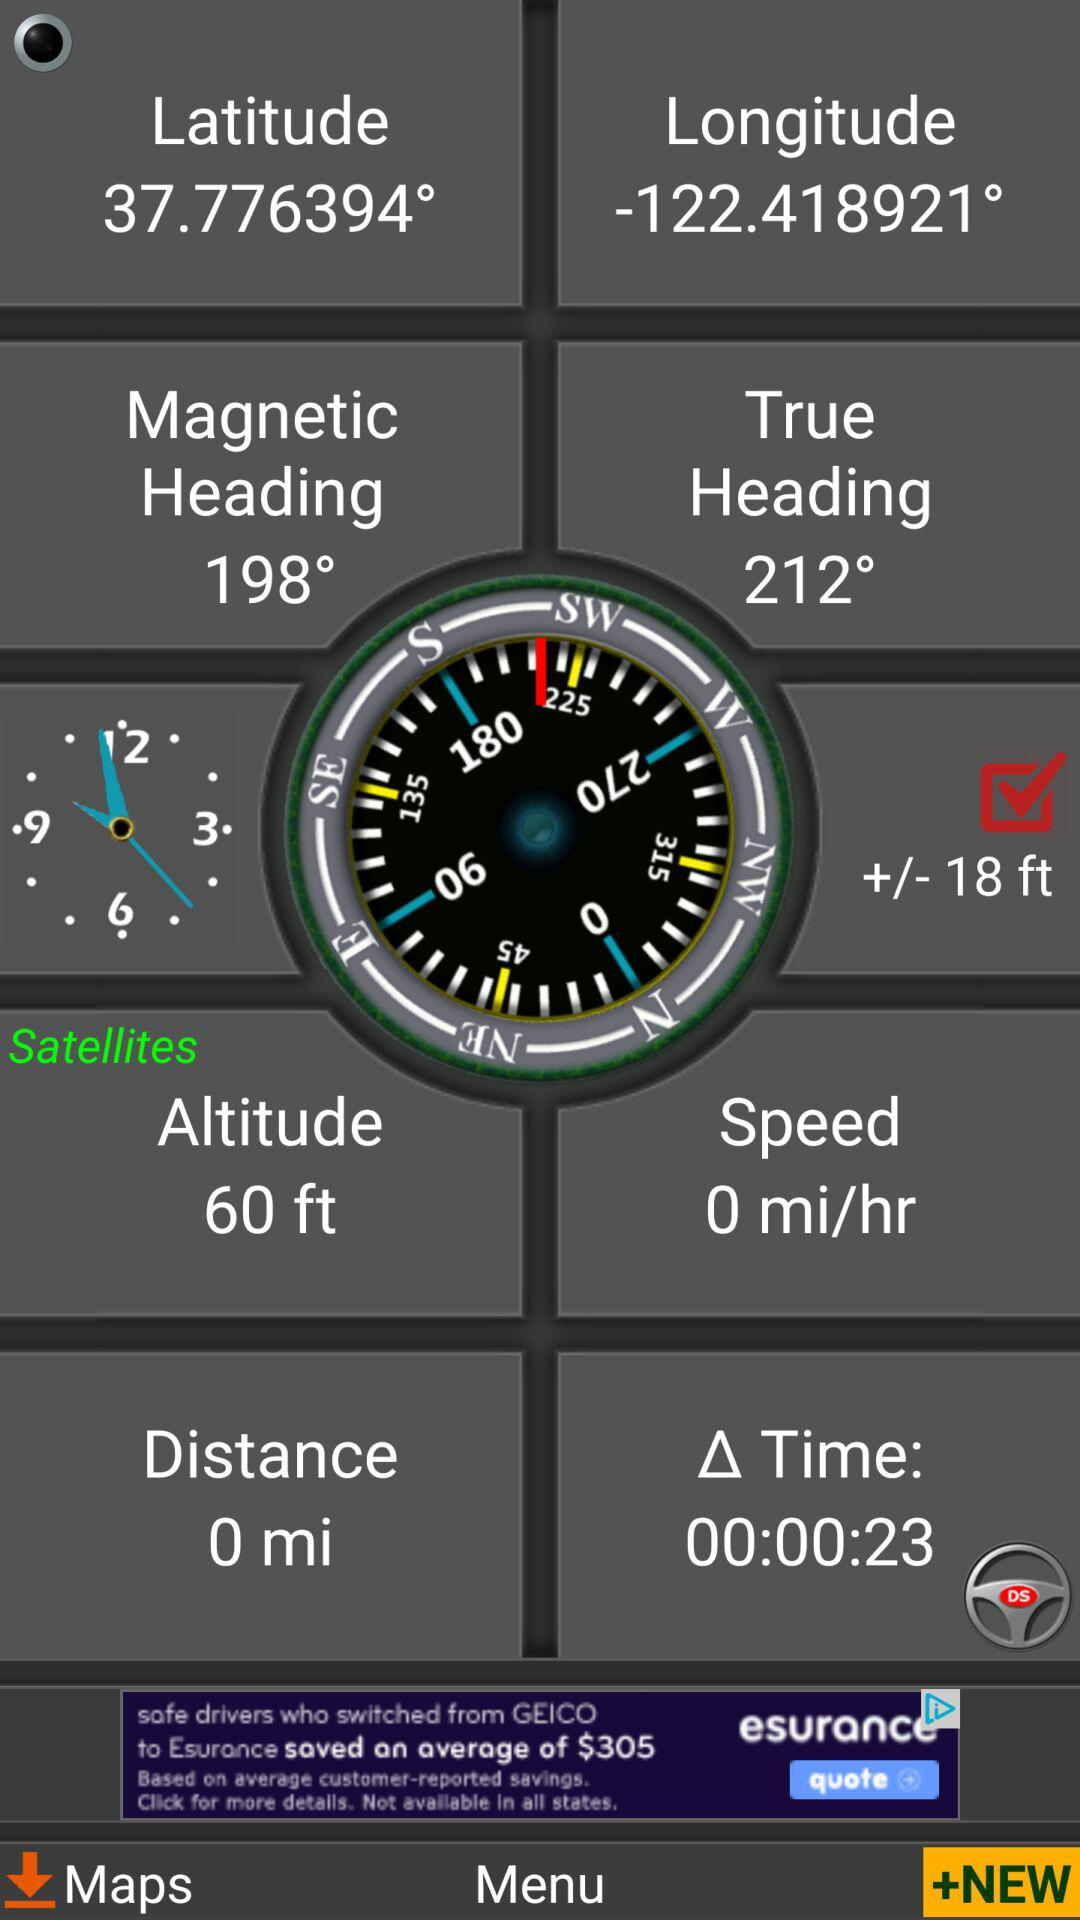What is the time duration? The time duration is 23 seconds. 